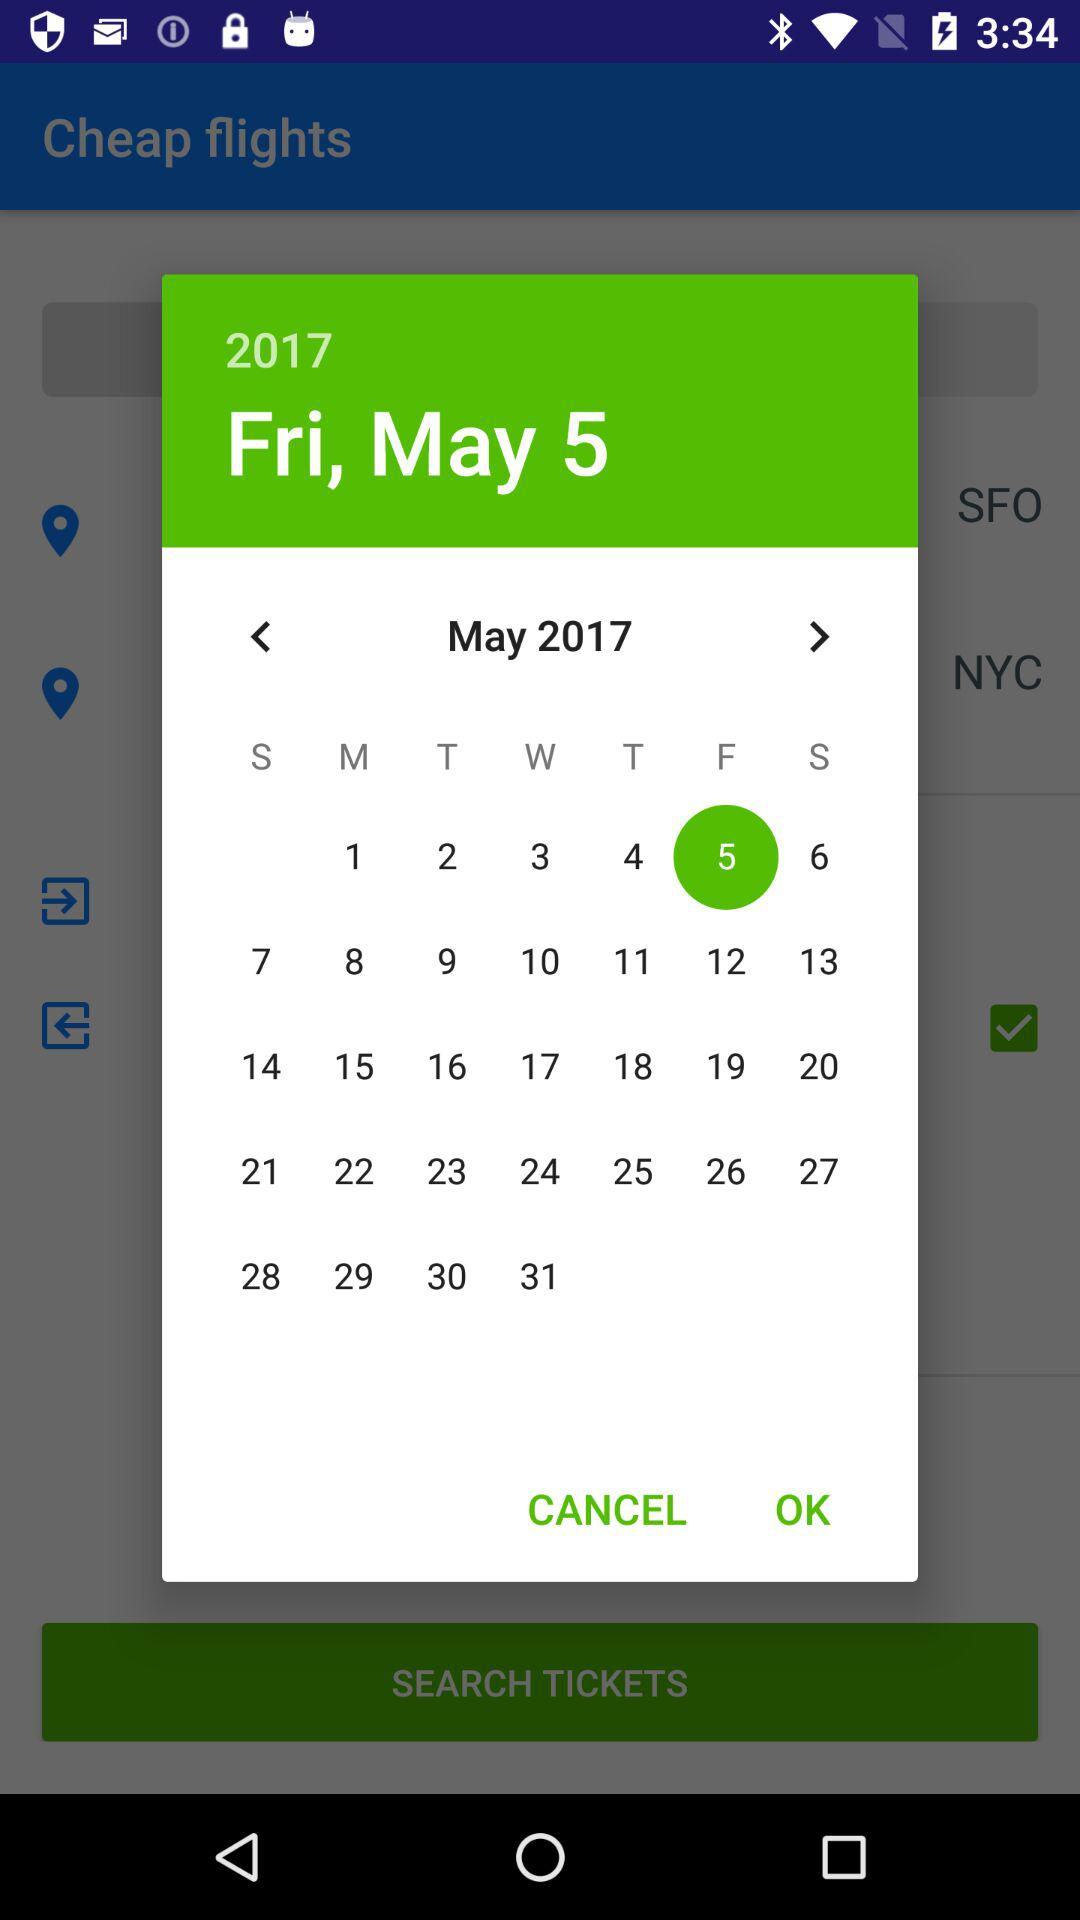How many days are left in the month?
Answer the question using a single word or phrase. 26 